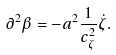Convert formula to latex. <formula><loc_0><loc_0><loc_500><loc_500>\partial ^ { 2 } \beta = - a ^ { 2 } \frac { 1 } { c _ { \zeta } ^ { 2 } } \dot { \zeta } .</formula> 